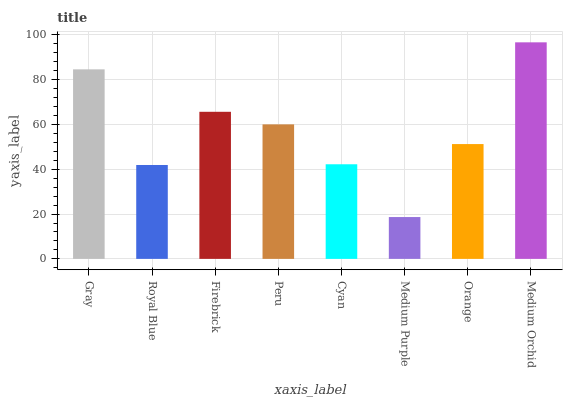Is Medium Purple the minimum?
Answer yes or no. Yes. Is Medium Orchid the maximum?
Answer yes or no. Yes. Is Royal Blue the minimum?
Answer yes or no. No. Is Royal Blue the maximum?
Answer yes or no. No. Is Gray greater than Royal Blue?
Answer yes or no. Yes. Is Royal Blue less than Gray?
Answer yes or no. Yes. Is Royal Blue greater than Gray?
Answer yes or no. No. Is Gray less than Royal Blue?
Answer yes or no. No. Is Peru the high median?
Answer yes or no. Yes. Is Orange the low median?
Answer yes or no. Yes. Is Firebrick the high median?
Answer yes or no. No. Is Gray the low median?
Answer yes or no. No. 